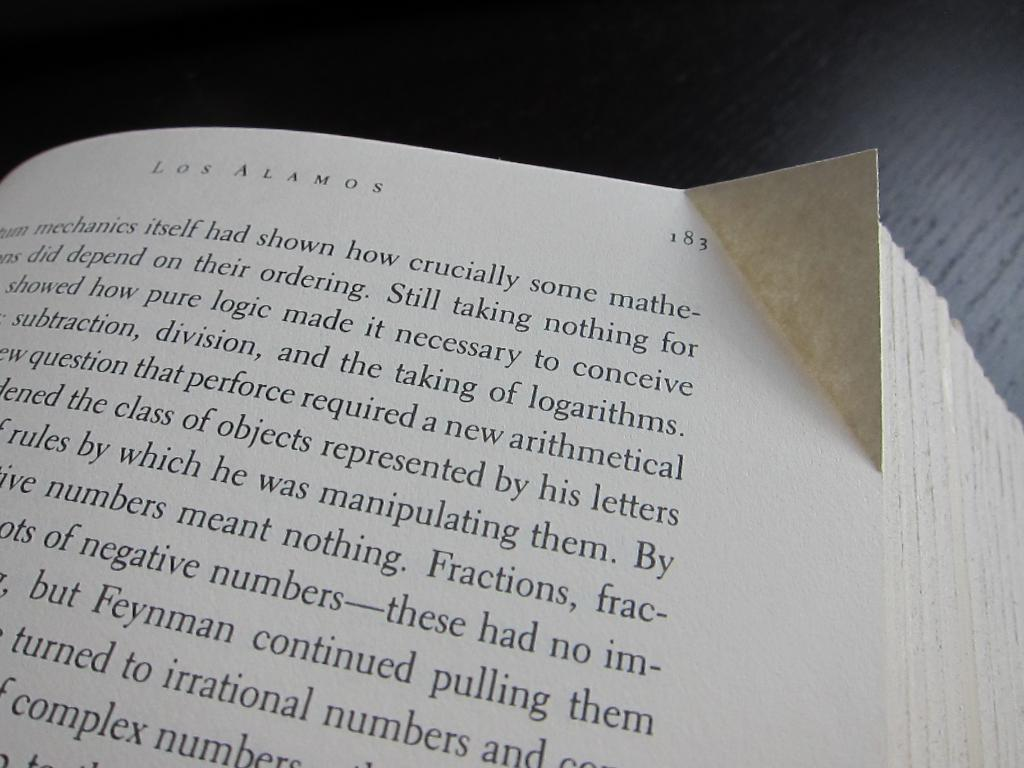<image>
Present a compact description of the photo's key features. Page 183 of this book has the word "crucially" on the top line. 